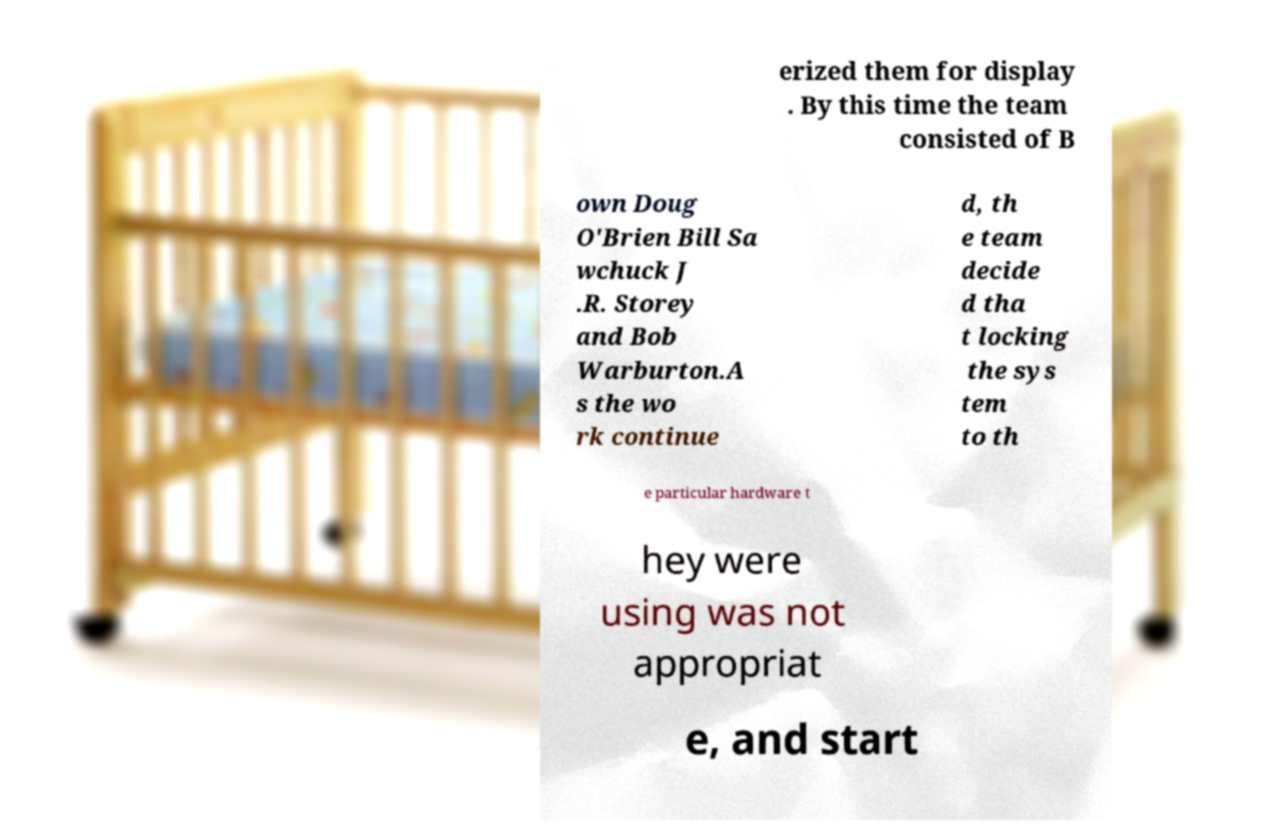Could you extract and type out the text from this image? erized them for display . By this time the team consisted of B own Doug O'Brien Bill Sa wchuck J .R. Storey and Bob Warburton.A s the wo rk continue d, th e team decide d tha t locking the sys tem to th e particular hardware t hey were using was not appropriat e, and start 